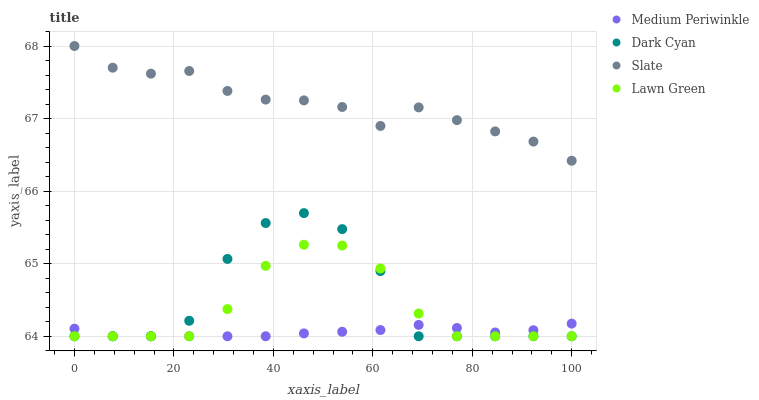Does Medium Periwinkle have the minimum area under the curve?
Answer yes or no. Yes. Does Slate have the maximum area under the curve?
Answer yes or no. Yes. Does Lawn Green have the minimum area under the curve?
Answer yes or no. No. Does Lawn Green have the maximum area under the curve?
Answer yes or no. No. Is Medium Periwinkle the smoothest?
Answer yes or no. Yes. Is Dark Cyan the roughest?
Answer yes or no. Yes. Is Lawn Green the smoothest?
Answer yes or no. No. Is Lawn Green the roughest?
Answer yes or no. No. Does Dark Cyan have the lowest value?
Answer yes or no. Yes. Does Slate have the lowest value?
Answer yes or no. No. Does Slate have the highest value?
Answer yes or no. Yes. Does Lawn Green have the highest value?
Answer yes or no. No. Is Medium Periwinkle less than Slate?
Answer yes or no. Yes. Is Slate greater than Lawn Green?
Answer yes or no. Yes. Does Lawn Green intersect Dark Cyan?
Answer yes or no. Yes. Is Lawn Green less than Dark Cyan?
Answer yes or no. No. Is Lawn Green greater than Dark Cyan?
Answer yes or no. No. Does Medium Periwinkle intersect Slate?
Answer yes or no. No. 